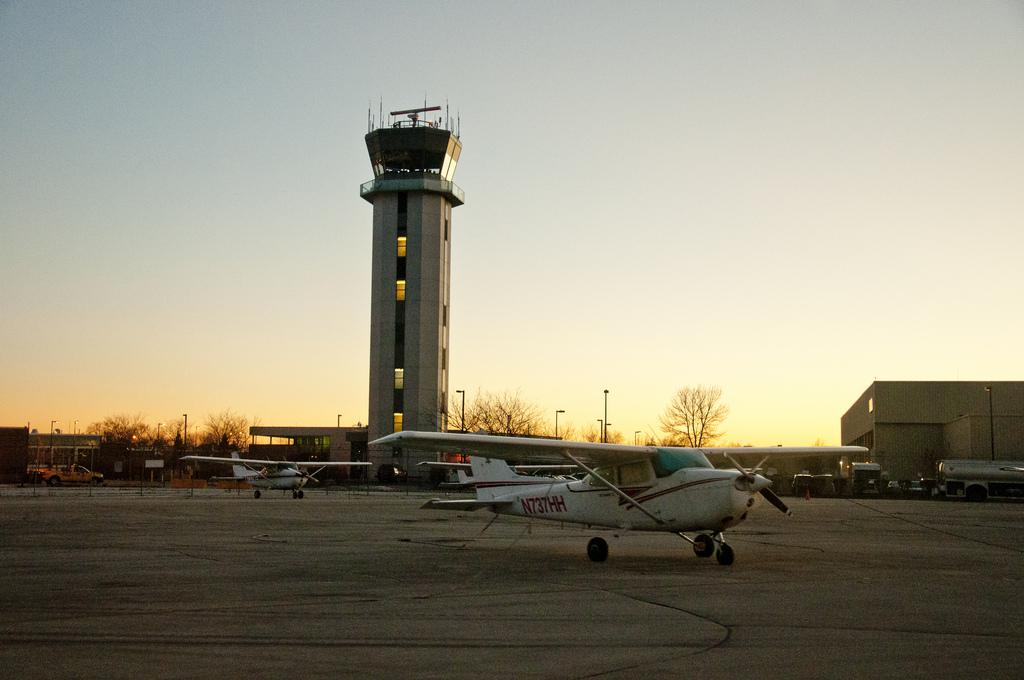Question: what is the main subject?
Choices:
A. The treeline.
B. The city building.
C. The tall girl.
D. The control tower.
Answer with the letter. Answer: D Question: what is in the foreground?
Choices:
A. A young boy.
B. Three cats.
C. An airplane.
D. A dog.
Answer with the letter. Answer: C Question: why do people use airplanes?
Choices:
A. For travel.
B. To see their friends.
C. To get over their fear of heights.
D. To become pilots.
Answer with the letter. Answer: A Question: where is this taken?
Choices:
A. An airfield.
B. In the city.
C. Behind the convienent store.
D. At home.
Answer with the letter. Answer: A Question: when was this taken?
Choices:
A. Midday.
B. Either dusk or dawn.
C. In the morning.
D. After lunch.
Answer with the letter. Answer: B Question: who flies the plane?
Choices:
A. The Captain.
B. A pilot.
C. The first officer.
D. The co-pilot.
Answer with the letter. Answer: B Question: where is the control tower?
Choices:
A. In the distance.
B. Behind the runway.
C. Behind the planes.
D. It is on the left.
Answer with the letter. Answer: C Question: what type of scene is it?
Choices:
A. A park.
B. Baseball.
C. An animal scene.
D. Outdoor scene.
Answer with the letter. Answer: D Question: what is setting?
Choices:
A. The sun.
B. Concrete.
C. Glue.
D. Cold.
Answer with the letter. Answer: A Question: what is rising high in the background?
Choices:
A. Smoke.
B. A air traffic control tower.
C. A plane.
D. Mountains.
Answer with the letter. Answer: B Question: where does the sun set?
Choices:
A. At the airport.
B. In the west.
C. Over the mountains.
D. Over the sea.
Answer with the letter. Answer: A Question: what size is the plane?
Choices:
A. Commercial jet.
B. Small.
C. Two-person plane.
D. Company jet.
Answer with the letter. Answer: B Question: what is in the distance?
Choices:
A. Fence.
B. The airport terminal.
C. Parking garage.
D. Control tower.
Answer with the letter. Answer: D Question: what are on top of the air traffic control tower?
Choices:
A. Windows.
B. Lights.
C. Roof.
D. Several antennas.
Answer with the letter. Answer: D Question: what is in the forefront?
Choices:
A. Luggage car.
B. Runway.
C. Airport.
D. A plane.
Answer with the letter. Answer: D Question: what can be seen on the far right of the image?
Choices:
A. A wheel.
B. Runway.
C. Part of a plane's wing.
D. Airport.
Answer with the letter. Answer: C 